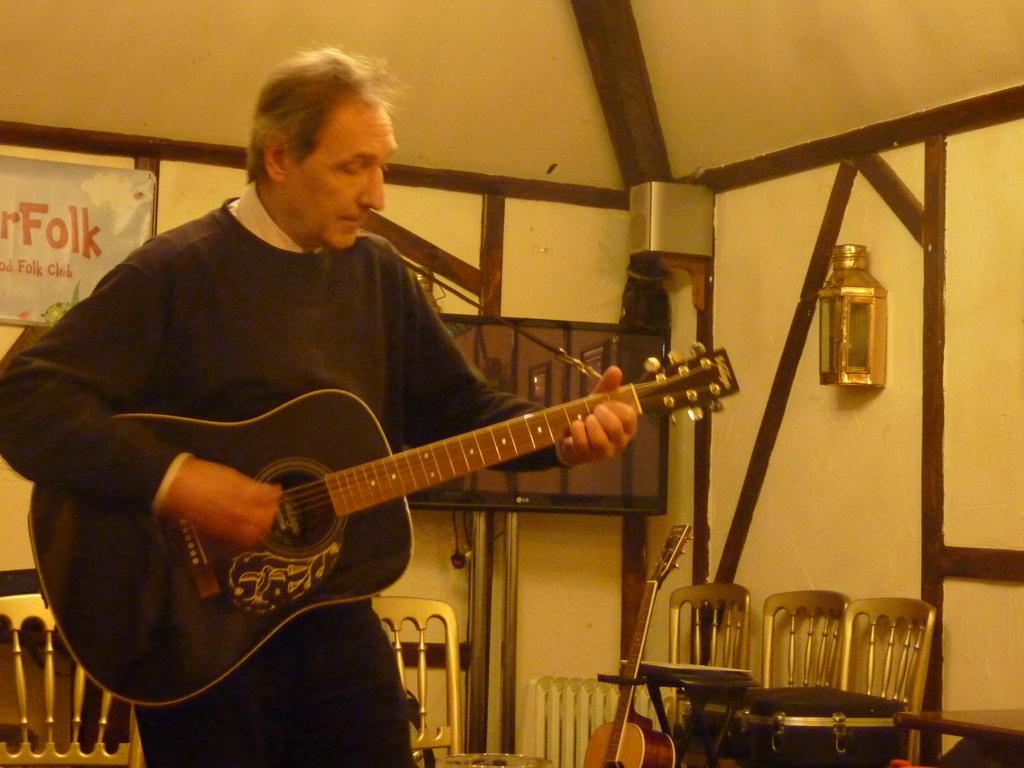In one or two sentences, can you explain what this image depicts? This is a board. Here we can see few empty chairs on the background. Here we can see one man standing and playing guitar. He wore black colour sweater. This is asos a guitar near to the chairs. 